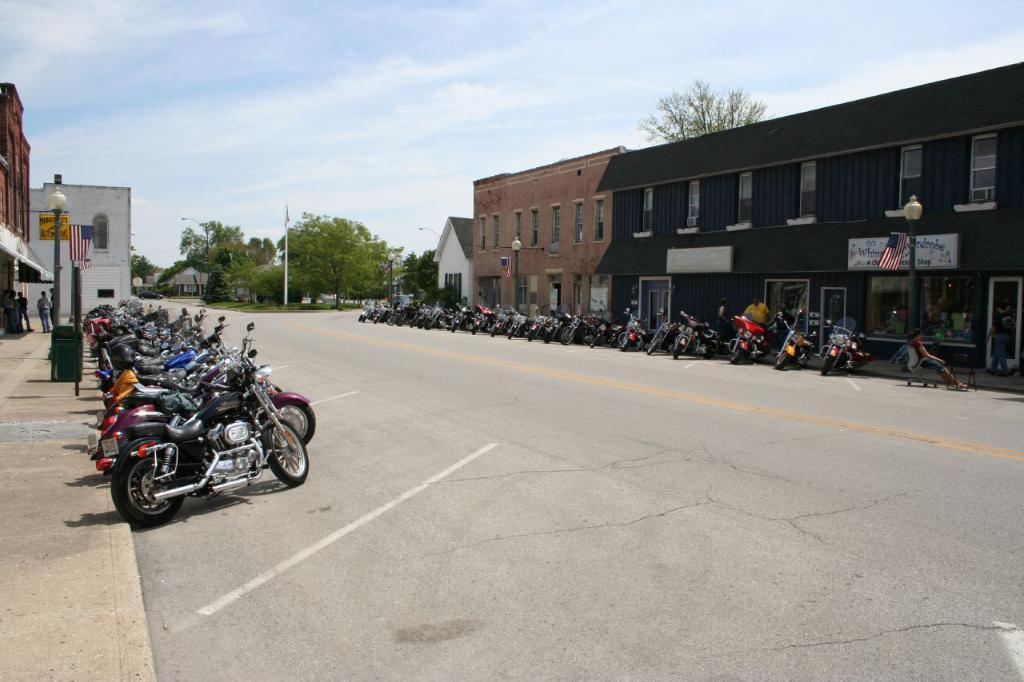Describe this image in one or two sentences. In this image there are bikes on the road. There are people standing on the pavement. There are street lights, flags. On the left side of the image there is a dustbin. On the right side of the image there is a person sitting on the chair. In the background of the image there are buildings, trees and sky. 